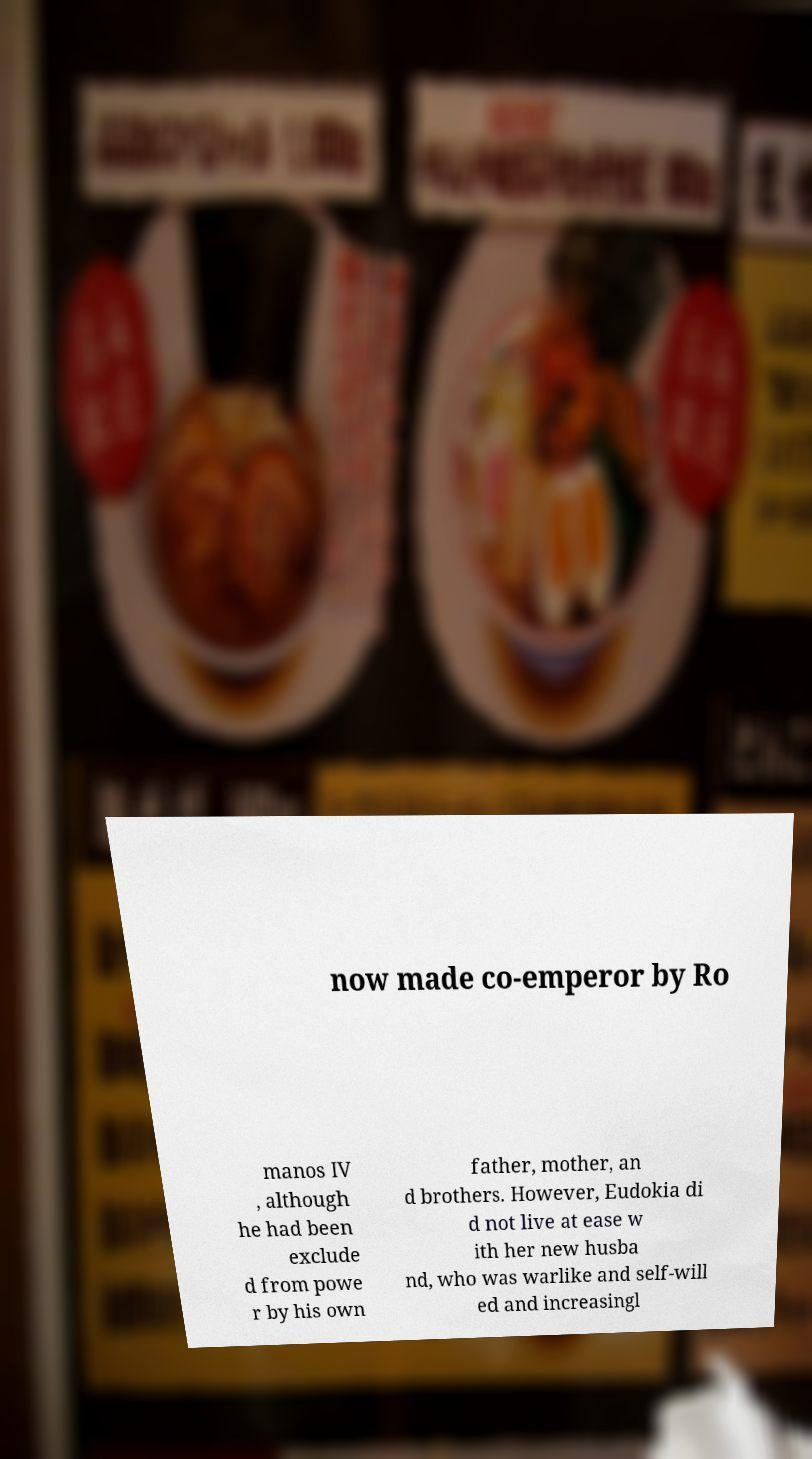Please read and relay the text visible in this image. What does it say? now made co-emperor by Ro manos IV , although he had been exclude d from powe r by his own father, mother, an d brothers. However, Eudokia di d not live at ease w ith her new husba nd, who was warlike and self-will ed and increasingl 